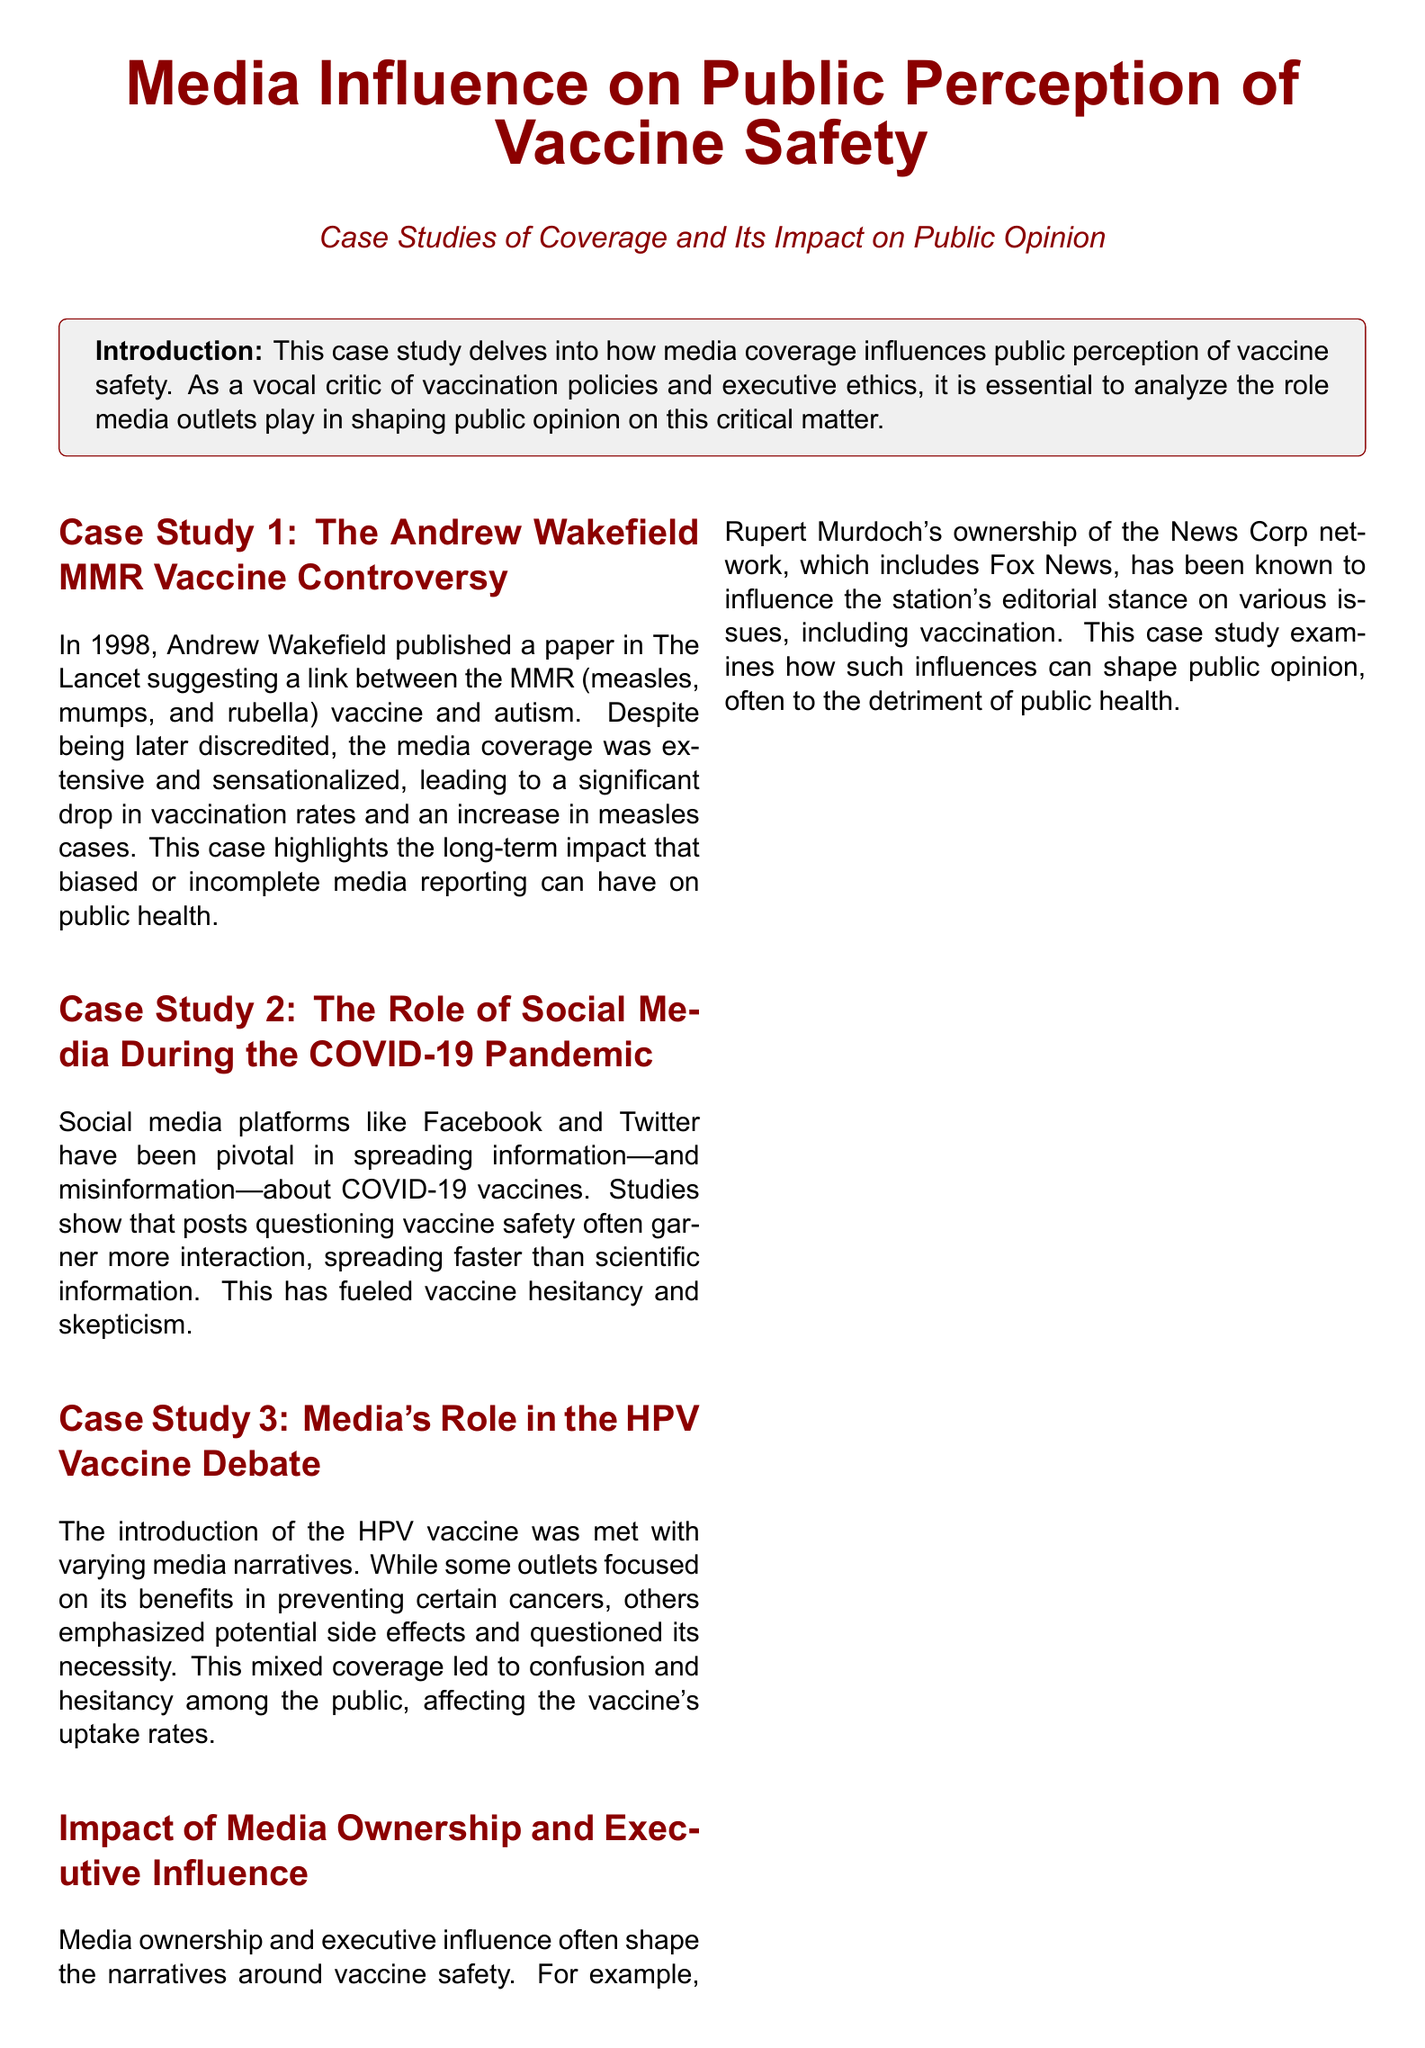What year was the Andrew Wakefield paper published? The document states that Andrew Wakefield published his paper in The Lancet in 1998, which is a specific year.
Answer: 1998 What was the focus of the first case study? The first case study discusses the Andrew Wakefield MMR vaccine controversy, highlighting its impact on vaccination rates and public health.
Answer: Andrew Wakefield MMR vaccine controversy What social media platforms are mentioned in the second case study? The document specifies Facebook and Twitter as the platforms discussed in terms of their influence on vaccine information spread during the COVID-19 pandemic.
Answer: Facebook and Twitter What was the impact of the HPV vaccine media narratives? According to the document, the mixed media coverage led to confusion and hesitancy among the public regarding the HPV vaccine's uptake rates.
Answer: Confusion and hesitancy Who owns the News Corp network mentioned in the document? The document indicates that Rupert Murdoch owns the News Corp network, an important detail related to media influence on vaccine narratives.
Answer: Rupert Murdoch What is the primary theme of the case studies presented in the document? The case studies collectively analyze how media coverage influences public perception of vaccine safety, emphasizing the need for scrutiny over executive motives.
Answer: Media influence on public perception of vaccine safety How does social media affect vaccine hesitancy according to the document? The document states that posts questioning vaccine safety gain more interaction and spread faster than scientific information, contributing to vaccine hesitancy.
Answer: Spreads faster than scientific information What is the conclusion drawn about media coverage in the document? The conclusion summarizes that media coverage plays a crucial role in shaping perception, urging for scrutiny on executive motives behind narratives.
Answer: Media coverage plays a crucial role in shaping perception 